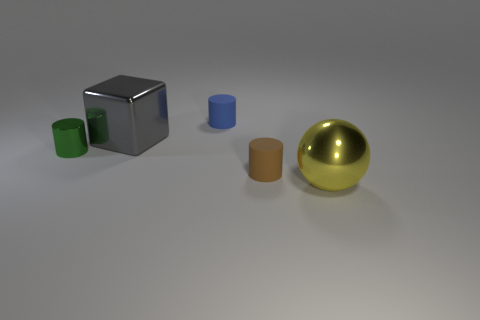Add 3 small things. How many objects exist? 8 Subtract all cylinders. How many objects are left? 2 Add 5 large red matte cylinders. How many large red matte cylinders exist? 5 Subtract 0 yellow cylinders. How many objects are left? 5 Subtract all tiny gray objects. Subtract all green cylinders. How many objects are left? 4 Add 5 small brown rubber objects. How many small brown rubber objects are left? 6 